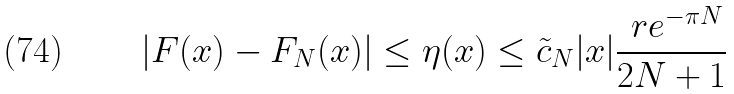<formula> <loc_0><loc_0><loc_500><loc_500>| F ( x ) - F _ { N } ( x ) | \leq \eta ( x ) \leq \tilde { c } _ { N } | x | \frac { \ r e ^ { - \pi N } } { 2 N + 1 }</formula> 